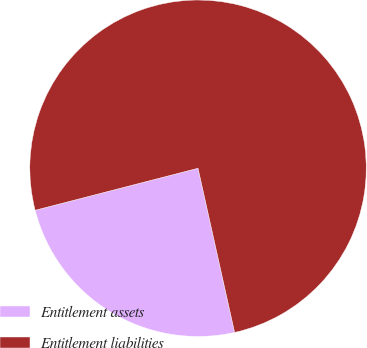Convert chart to OTSL. <chart><loc_0><loc_0><loc_500><loc_500><pie_chart><fcel>Entitlement assets<fcel>Entitlement liabilities<nl><fcel>24.47%<fcel>75.53%<nl></chart> 